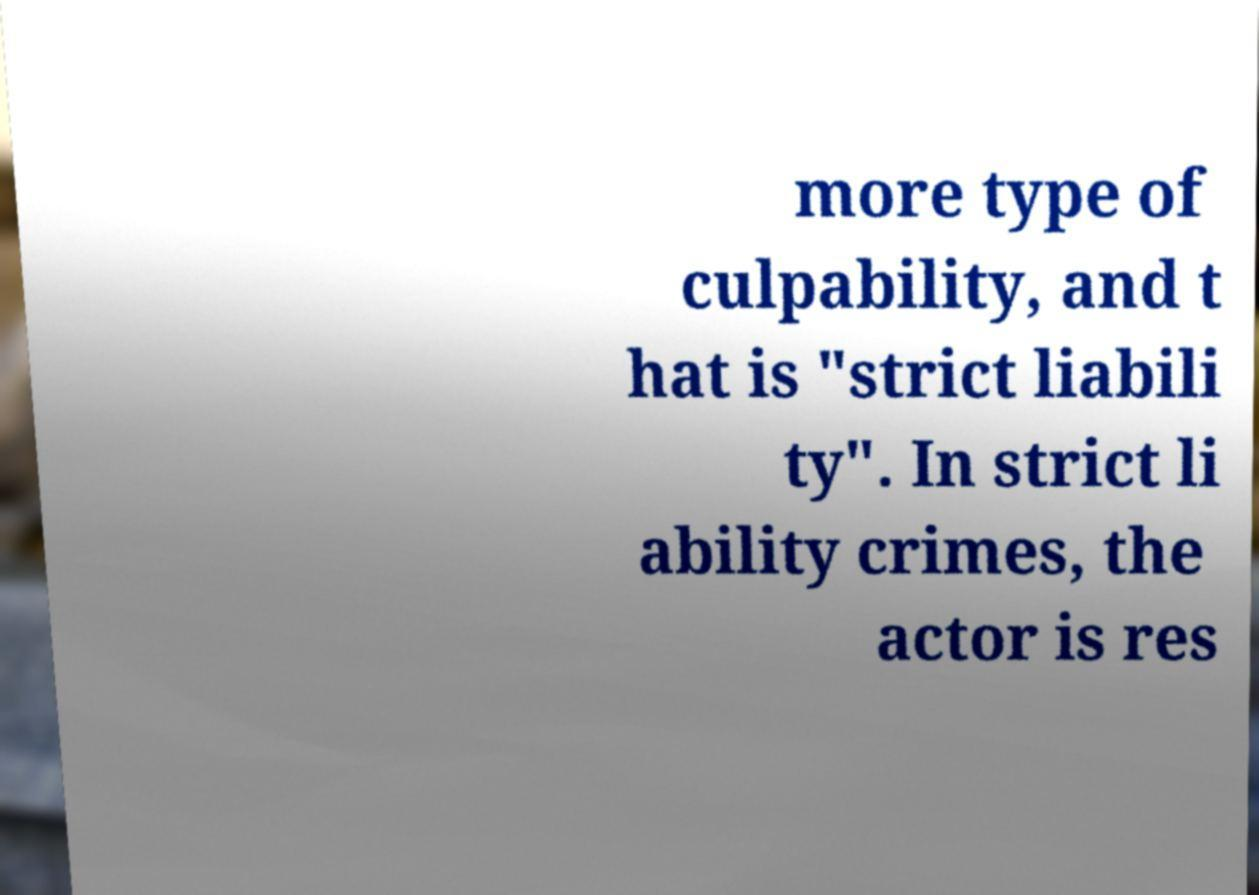Could you assist in decoding the text presented in this image and type it out clearly? more type of culpability, and t hat is "strict liabili ty". In strict li ability crimes, the actor is res 